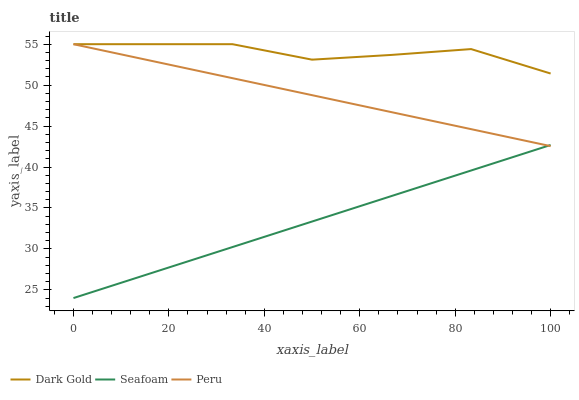Does Seafoam have the minimum area under the curve?
Answer yes or no. Yes. Does Dark Gold have the maximum area under the curve?
Answer yes or no. Yes. Does Peru have the minimum area under the curve?
Answer yes or no. No. Does Peru have the maximum area under the curve?
Answer yes or no. No. Is Seafoam the smoothest?
Answer yes or no. Yes. Is Dark Gold the roughest?
Answer yes or no. Yes. Is Peru the smoothest?
Answer yes or no. No. Is Peru the roughest?
Answer yes or no. No. Does Seafoam have the lowest value?
Answer yes or no. Yes. Does Peru have the lowest value?
Answer yes or no. No. Does Dark Gold have the highest value?
Answer yes or no. Yes. Is Seafoam less than Dark Gold?
Answer yes or no. Yes. Is Dark Gold greater than Seafoam?
Answer yes or no. Yes. Does Dark Gold intersect Peru?
Answer yes or no. Yes. Is Dark Gold less than Peru?
Answer yes or no. No. Is Dark Gold greater than Peru?
Answer yes or no. No. Does Seafoam intersect Dark Gold?
Answer yes or no. No. 